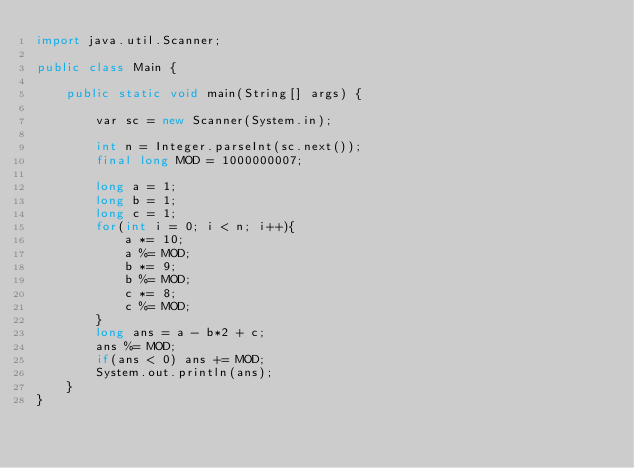<code> <loc_0><loc_0><loc_500><loc_500><_Java_>import java.util.Scanner;

public class Main {

    public static void main(String[] args) {
        
        var sc = new Scanner(System.in);
        
        int n = Integer.parseInt(sc.next());
        final long MOD = 1000000007;
        
        long a = 1;
        long b = 1;
        long c = 1;
        for(int i = 0; i < n; i++){
            a *= 10;
            a %= MOD;
            b *= 9;
            b %= MOD;
            c *= 8;
            c %= MOD;
        }
        long ans = a - b*2 + c;
        ans %= MOD;
        if(ans < 0) ans += MOD;
        System.out.println(ans);
    }
}</code> 